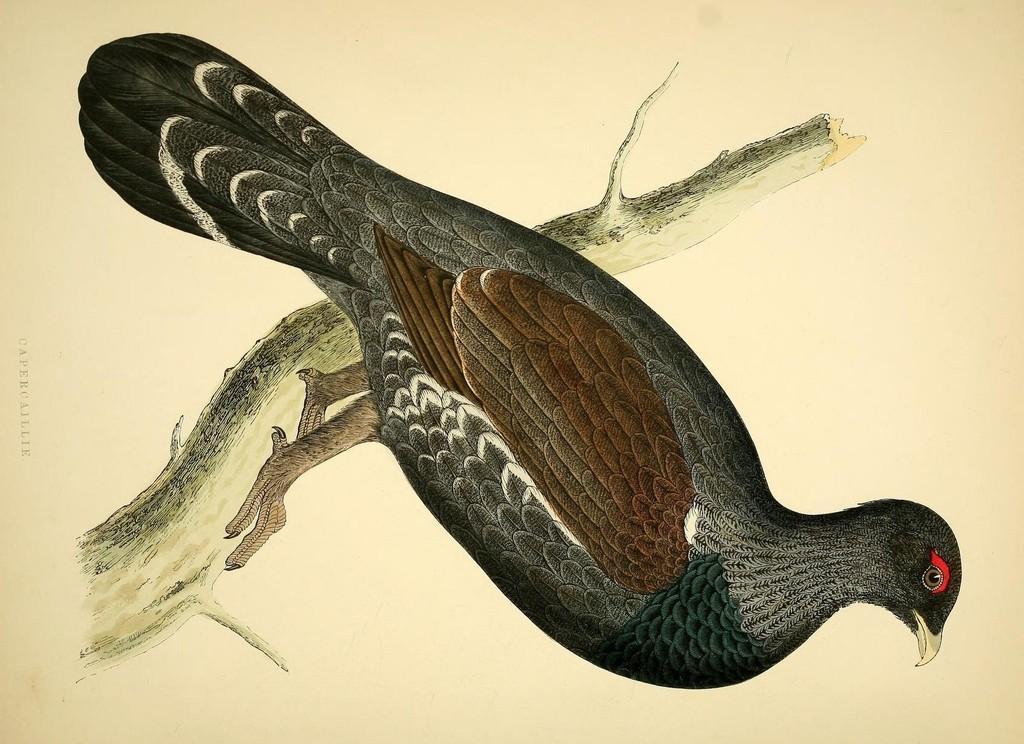Can you describe this image briefly? Here we can see painting of a bird on stem. 